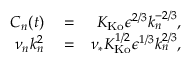Convert formula to latex. <formula><loc_0><loc_0><loc_500><loc_500>\begin{array} { r l r } { C _ { n } ( t ) } & = } & { K _ { K o } \epsilon ^ { 2 / 3 } k _ { n } ^ { - 2 / 3 } , } \\ { \nu _ { n } k _ { n } ^ { 2 } } & = } & { \nu _ { * } K _ { K o } ^ { 1 / 2 } \epsilon ^ { 1 / 3 } k _ { n } ^ { 2 / 3 } , } \end{array}</formula> 